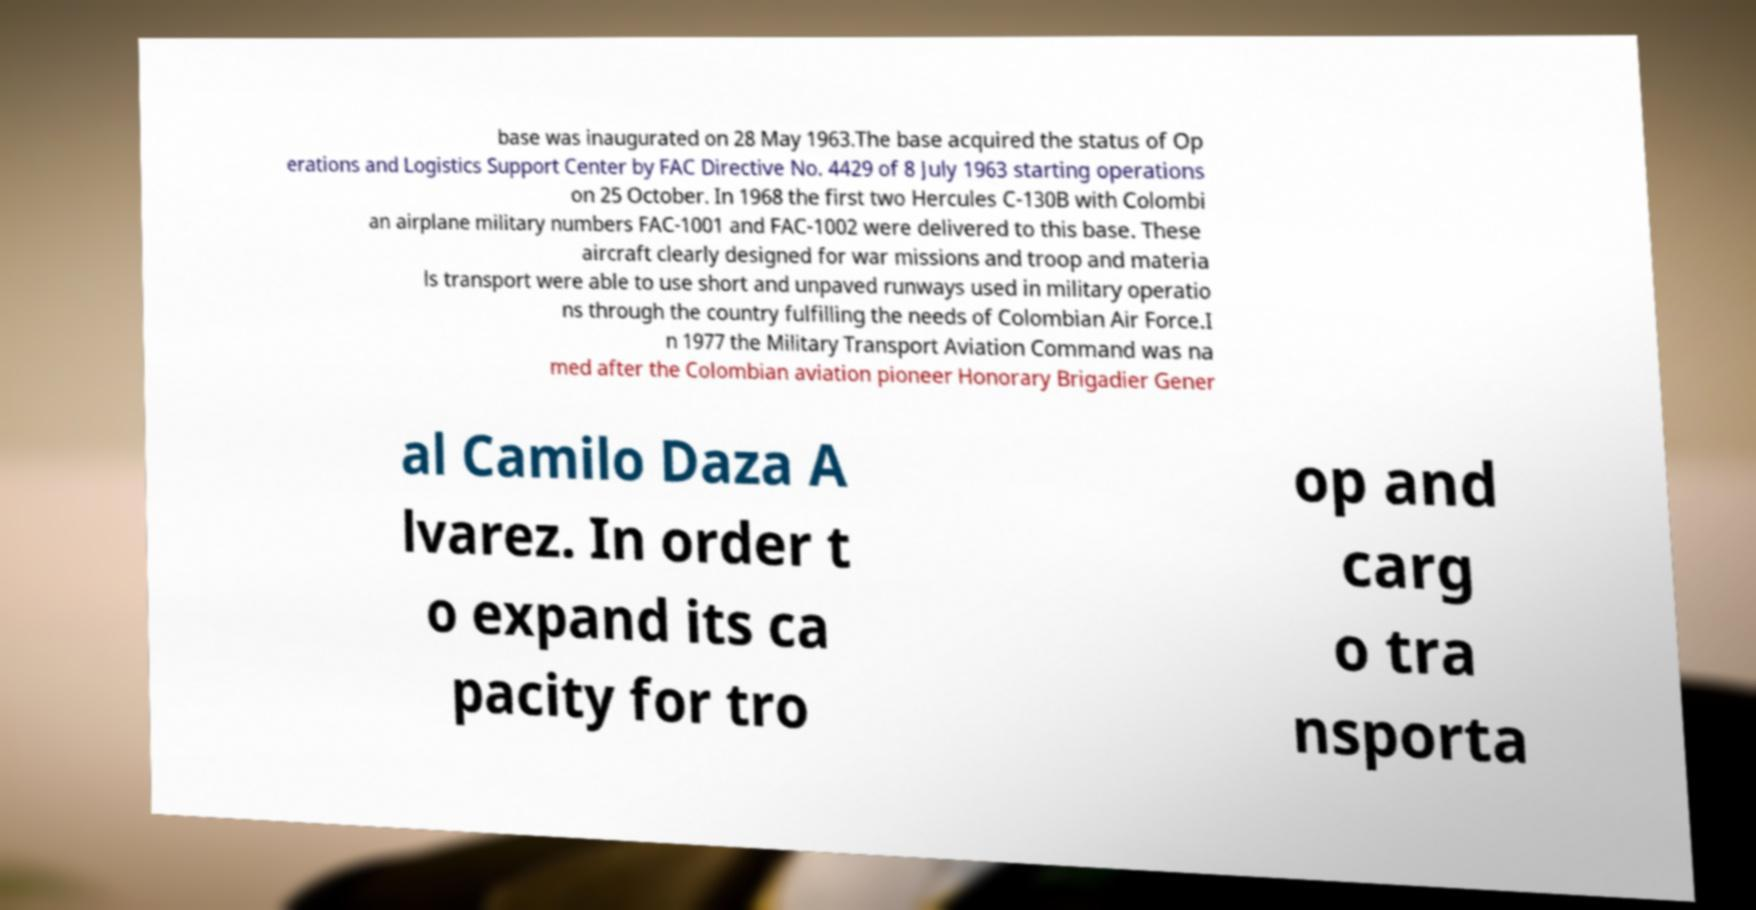Could you assist in decoding the text presented in this image and type it out clearly? base was inaugurated on 28 May 1963.The base acquired the status of Op erations and Logistics Support Center by FAC Directive No. 4429 of 8 July 1963 starting operations on 25 October. In 1968 the first two Hercules C-130B with Colombi an airplane military numbers FAC-1001 and FAC-1002 were delivered to this base. These aircraft clearly designed for war missions and troop and materia ls transport were able to use short and unpaved runways used in military operatio ns through the country fulfilling the needs of Colombian Air Force.I n 1977 the Military Transport Aviation Command was na med after the Colombian aviation pioneer Honorary Brigadier Gener al Camilo Daza A lvarez. In order t o expand its ca pacity for tro op and carg o tra nsporta 